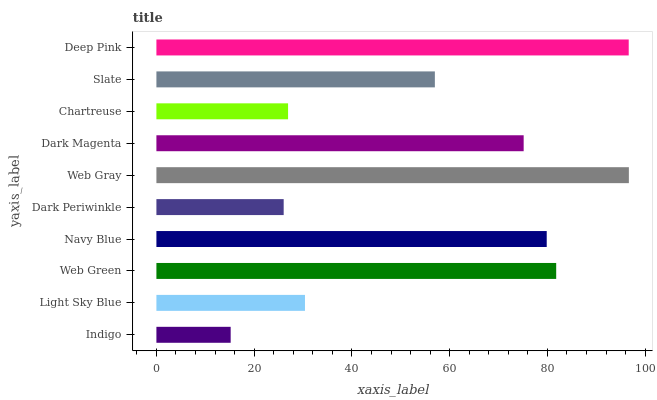Is Indigo the minimum?
Answer yes or no. Yes. Is Web Gray the maximum?
Answer yes or no. Yes. Is Light Sky Blue the minimum?
Answer yes or no. No. Is Light Sky Blue the maximum?
Answer yes or no. No. Is Light Sky Blue greater than Indigo?
Answer yes or no. Yes. Is Indigo less than Light Sky Blue?
Answer yes or no. Yes. Is Indigo greater than Light Sky Blue?
Answer yes or no. No. Is Light Sky Blue less than Indigo?
Answer yes or no. No. Is Dark Magenta the high median?
Answer yes or no. Yes. Is Slate the low median?
Answer yes or no. Yes. Is Dark Periwinkle the high median?
Answer yes or no. No. Is Web Green the low median?
Answer yes or no. No. 